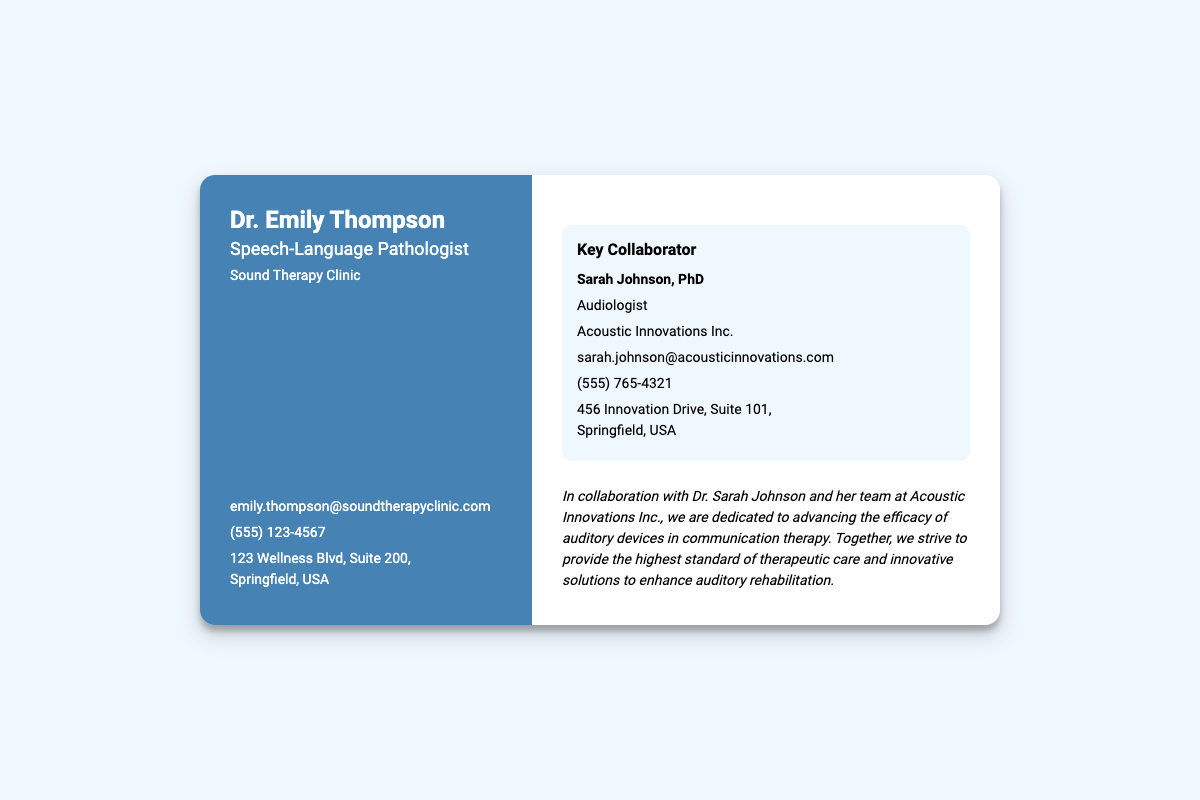What is Dr. Emily Thompson's profession? The document states that Dr. Emily Thompson is a Speech-Language Pathologist.
Answer: Speech-Language Pathologist What is the name of Dr. Emily Thompson's clinic? According to the document, Dr. Emily Thompson works at the Sound Therapy Clinic.
Answer: Sound Therapy Clinic Who is the key collaborator mentioned in the document? The document identifies Sarah Johnson, PhD, as the key collaborator.
Answer: Sarah Johnson, PhD What is the contact email for Sarah Johnson? The document provides the email address for Sarah Johnson as sarah.johnson@acousticinnovations.com.
Answer: sarah.johnson@acousticinnovations.com What is the address of Dr. Emily Thompson's clinic? The address listed in the document for Dr. Emily Thompson is 123 Wellness Blvd, Suite 200, Springfield, USA.
Answer: 123 Wellness Blvd, Suite 200, Springfield, USA What company does Sarah Johnson work for? The document states that Sarah Johnson works at Acoustic Innovations Inc.
Answer: Acoustic Innovations Inc What is the importance of the partnership mentioned in the document? The partnership aims to advance the efficacy of auditory devices in communication therapy.
Answer: Advancing the efficacy of auditory devices in communication therapy How many phone numbers are provided in the document? There are two phone numbers given, one for Dr. Emily Thompson and one for Sarah Johnson.
Answer: Two What type of document is this? The structure and content suggest that this is a business card.
Answer: Business card 